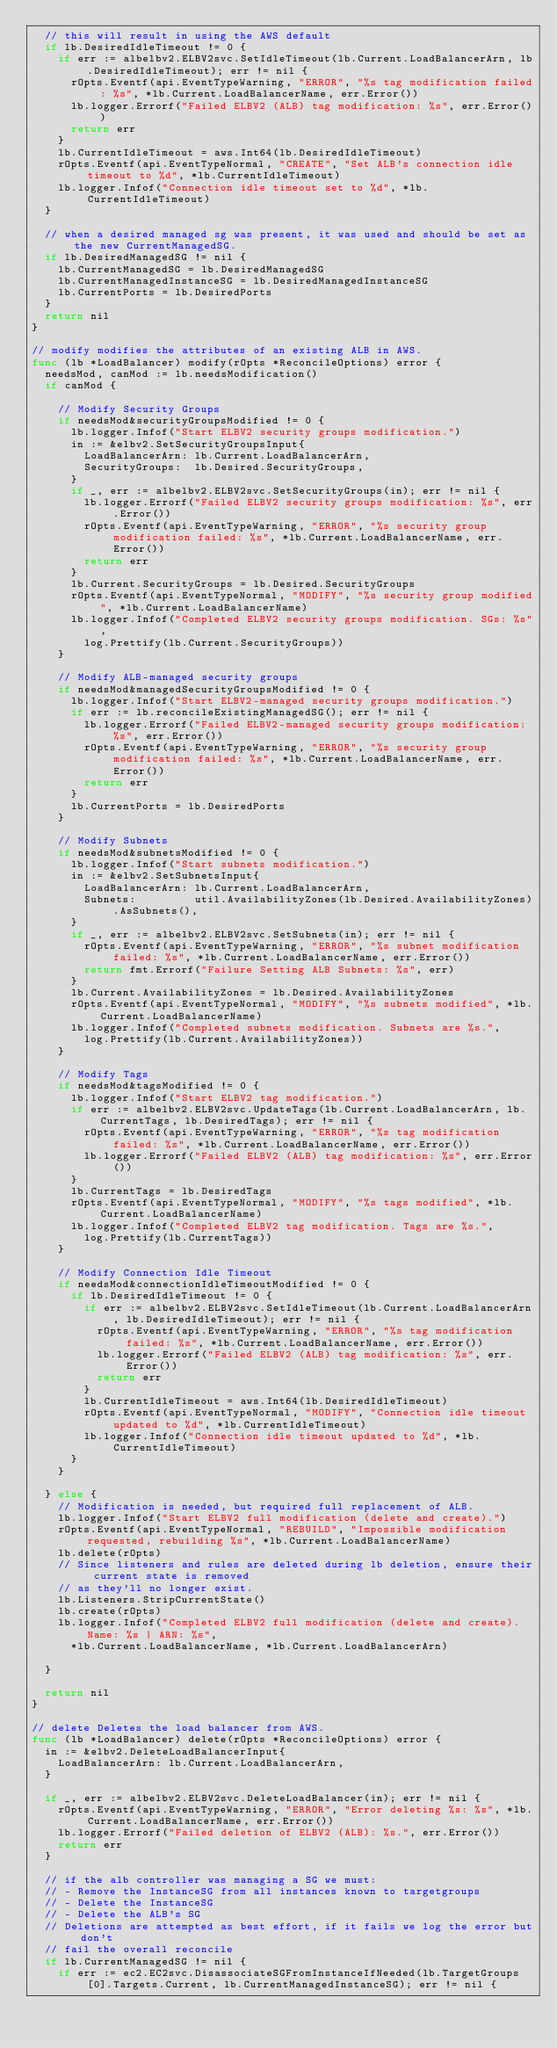Convert code to text. <code><loc_0><loc_0><loc_500><loc_500><_Go_>	// this will result in using the AWS default
	if lb.DesiredIdleTimeout != 0 {
		if err := albelbv2.ELBV2svc.SetIdleTimeout(lb.Current.LoadBalancerArn, lb.DesiredIdleTimeout); err != nil {
			rOpts.Eventf(api.EventTypeWarning, "ERROR", "%s tag modification failed: %s", *lb.Current.LoadBalancerName, err.Error())
			lb.logger.Errorf("Failed ELBV2 (ALB) tag modification: %s", err.Error())
			return err
		}
		lb.CurrentIdleTimeout = aws.Int64(lb.DesiredIdleTimeout)
		rOpts.Eventf(api.EventTypeNormal, "CREATE", "Set ALB's connection idle timeout to %d", *lb.CurrentIdleTimeout)
		lb.logger.Infof("Connection idle timeout set to %d", *lb.CurrentIdleTimeout)
	}

	// when a desired managed sg was present, it was used and should be set as the new CurrentManagedSG.
	if lb.DesiredManagedSG != nil {
		lb.CurrentManagedSG = lb.DesiredManagedSG
		lb.CurrentManagedInstanceSG = lb.DesiredManagedInstanceSG
		lb.CurrentPorts = lb.DesiredPorts
	}
	return nil
}

// modify modifies the attributes of an existing ALB in AWS.
func (lb *LoadBalancer) modify(rOpts *ReconcileOptions) error {
	needsMod, canMod := lb.needsModification()
	if canMod {

		// Modify Security Groups
		if needsMod&securityGroupsModified != 0 {
			lb.logger.Infof("Start ELBV2 security groups modification.")
			in := &elbv2.SetSecurityGroupsInput{
				LoadBalancerArn: lb.Current.LoadBalancerArn,
				SecurityGroups:  lb.Desired.SecurityGroups,
			}
			if _, err := albelbv2.ELBV2svc.SetSecurityGroups(in); err != nil {
				lb.logger.Errorf("Failed ELBV2 security groups modification: %s", err.Error())
				rOpts.Eventf(api.EventTypeWarning, "ERROR", "%s security group modification failed: %s", *lb.Current.LoadBalancerName, err.Error())
				return err
			}
			lb.Current.SecurityGroups = lb.Desired.SecurityGroups
			rOpts.Eventf(api.EventTypeNormal, "MODIFY", "%s security group modified", *lb.Current.LoadBalancerName)
			lb.logger.Infof("Completed ELBV2 security groups modification. SGs: %s",
				log.Prettify(lb.Current.SecurityGroups))
		}

		// Modify ALB-managed security groups
		if needsMod&managedSecurityGroupsModified != 0 {
			lb.logger.Infof("Start ELBV2-managed security groups modification.")
			if err := lb.reconcileExistingManagedSG(); err != nil {
				lb.logger.Errorf("Failed ELBV2-managed security groups modification: %s", err.Error())
				rOpts.Eventf(api.EventTypeWarning, "ERROR", "%s security group modification failed: %s", *lb.Current.LoadBalancerName, err.Error())
				return err
			}
			lb.CurrentPorts = lb.DesiredPorts
		}

		// Modify Subnets
		if needsMod&subnetsModified != 0 {
			lb.logger.Infof("Start subnets modification.")
			in := &elbv2.SetSubnetsInput{
				LoadBalancerArn: lb.Current.LoadBalancerArn,
				Subnets:         util.AvailabilityZones(lb.Desired.AvailabilityZones).AsSubnets(),
			}
			if _, err := albelbv2.ELBV2svc.SetSubnets(in); err != nil {
				rOpts.Eventf(api.EventTypeWarning, "ERROR", "%s subnet modification failed: %s", *lb.Current.LoadBalancerName, err.Error())
				return fmt.Errorf("Failure Setting ALB Subnets: %s", err)
			}
			lb.Current.AvailabilityZones = lb.Desired.AvailabilityZones
			rOpts.Eventf(api.EventTypeNormal, "MODIFY", "%s subnets modified", *lb.Current.LoadBalancerName)
			lb.logger.Infof("Completed subnets modification. Subnets are %s.",
				log.Prettify(lb.Current.AvailabilityZones))
		}

		// Modify Tags
		if needsMod&tagsModified != 0 {
			lb.logger.Infof("Start ELBV2 tag modification.")
			if err := albelbv2.ELBV2svc.UpdateTags(lb.Current.LoadBalancerArn, lb.CurrentTags, lb.DesiredTags); err != nil {
				rOpts.Eventf(api.EventTypeWarning, "ERROR", "%s tag modification failed: %s", *lb.Current.LoadBalancerName, err.Error())
				lb.logger.Errorf("Failed ELBV2 (ALB) tag modification: %s", err.Error())
			}
			lb.CurrentTags = lb.DesiredTags
			rOpts.Eventf(api.EventTypeNormal, "MODIFY", "%s tags modified", *lb.Current.LoadBalancerName)
			lb.logger.Infof("Completed ELBV2 tag modification. Tags are %s.",
				log.Prettify(lb.CurrentTags))
		}

		// Modify Connection Idle Timeout
		if needsMod&connectionIdleTimeoutModified != 0 {
			if lb.DesiredIdleTimeout != 0 {
				if err := albelbv2.ELBV2svc.SetIdleTimeout(lb.Current.LoadBalancerArn, lb.DesiredIdleTimeout); err != nil {
					rOpts.Eventf(api.EventTypeWarning, "ERROR", "%s tag modification failed: %s", *lb.Current.LoadBalancerName, err.Error())
					lb.logger.Errorf("Failed ELBV2 (ALB) tag modification: %s", err.Error())
					return err
				}
				lb.CurrentIdleTimeout = aws.Int64(lb.DesiredIdleTimeout)
				rOpts.Eventf(api.EventTypeNormal, "MODIFY", "Connection idle timeout updated to %d", *lb.CurrentIdleTimeout)
				lb.logger.Infof("Connection idle timeout updated to %d", *lb.CurrentIdleTimeout)
			}
		}

	} else {
		// Modification is needed, but required full replacement of ALB.
		lb.logger.Infof("Start ELBV2 full modification (delete and create).")
		rOpts.Eventf(api.EventTypeNormal, "REBUILD", "Impossible modification requested, rebuilding %s", *lb.Current.LoadBalancerName)
		lb.delete(rOpts)
		// Since listeners and rules are deleted during lb deletion, ensure their current state is removed
		// as they'll no longer exist.
		lb.Listeners.StripCurrentState()
		lb.create(rOpts)
		lb.logger.Infof("Completed ELBV2 full modification (delete and create). Name: %s | ARN: %s",
			*lb.Current.LoadBalancerName, *lb.Current.LoadBalancerArn)

	}

	return nil
}

// delete Deletes the load balancer from AWS.
func (lb *LoadBalancer) delete(rOpts *ReconcileOptions) error {
	in := &elbv2.DeleteLoadBalancerInput{
		LoadBalancerArn: lb.Current.LoadBalancerArn,
	}

	if _, err := albelbv2.ELBV2svc.DeleteLoadBalancer(in); err != nil {
		rOpts.Eventf(api.EventTypeWarning, "ERROR", "Error deleting %s: %s", *lb.Current.LoadBalancerName, err.Error())
		lb.logger.Errorf("Failed deletion of ELBV2 (ALB): %s.", err.Error())
		return err
	}

	// if the alb controller was managing a SG we must:
	// - Remove the InstanceSG from all instances known to targetgroups
	// - Delete the InstanceSG
	// - Delete the ALB's SG
	// Deletions are attempted as best effort, if it fails we log the error but don't
	// fail the overall reconcile
	if lb.CurrentManagedSG != nil {
		if err := ec2.EC2svc.DisassociateSGFromInstanceIfNeeded(lb.TargetGroups[0].Targets.Current, lb.CurrentManagedInstanceSG); err != nil {</code> 